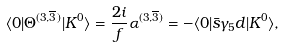Convert formula to latex. <formula><loc_0><loc_0><loc_500><loc_500>\langle 0 | \Theta ^ { ( 3 , \overline { 3 } ) } | K ^ { 0 } \rangle = \frac { 2 i } { f } \alpha ^ { ( 3 , \overline { 3 } ) } = - \langle 0 | \bar { s } \gamma _ { 5 } d | K ^ { 0 } \rangle ,</formula> 